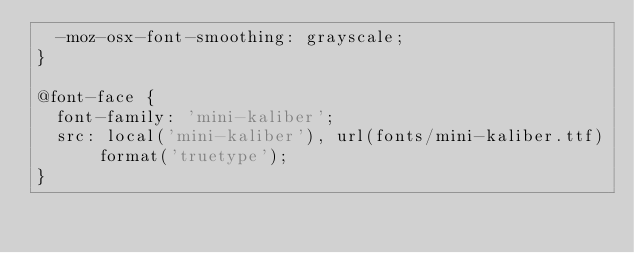<code> <loc_0><loc_0><loc_500><loc_500><_CSS_>  -moz-osx-font-smoothing: grayscale;
}

@font-face {
  font-family: 'mini-kaliber';
  src: local('mini-kaliber'), url(fonts/mini-kaliber.ttf) format('truetype');
}

</code> 